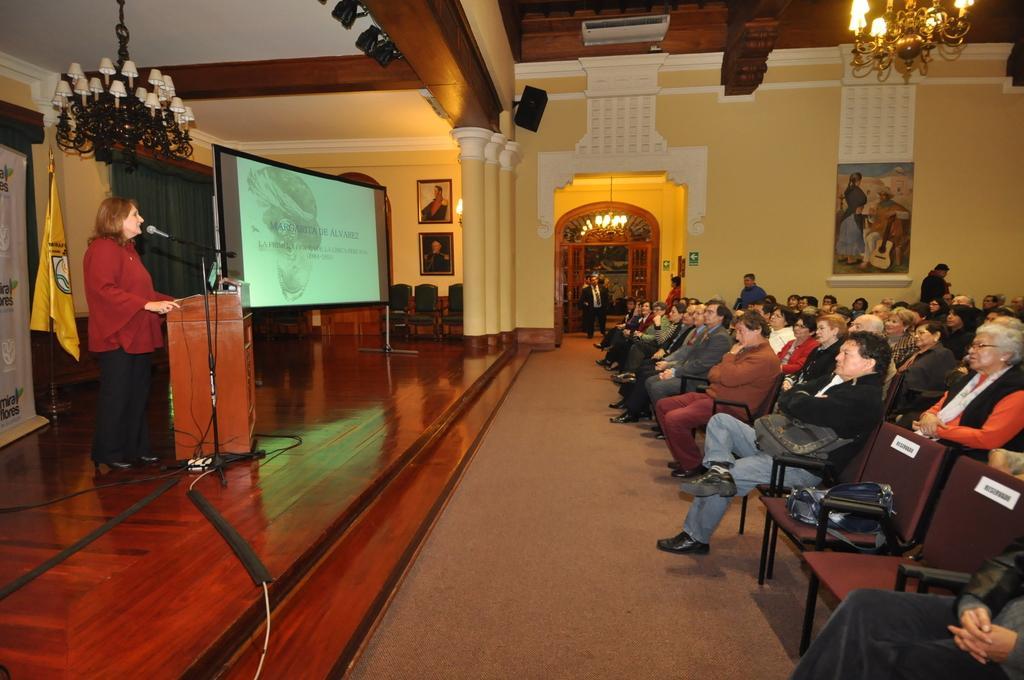In one or two sentences, can you explain what this image depicts? In this picture we can see group of people are seated on the chair in front of them a woman is speaking with the help of microphone and also we can find a projector screen a flag and couple of lights. 